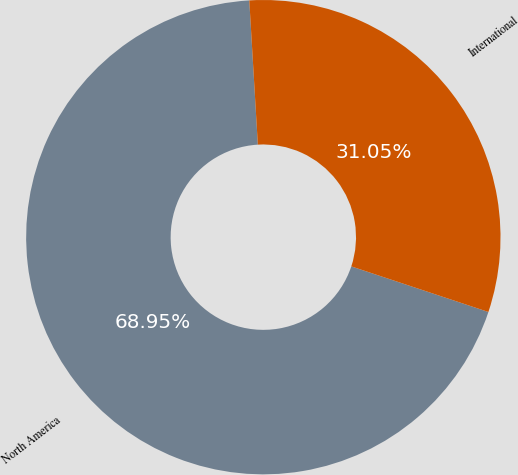<chart> <loc_0><loc_0><loc_500><loc_500><pie_chart><fcel>North America<fcel>International<nl><fcel>68.95%<fcel>31.05%<nl></chart> 